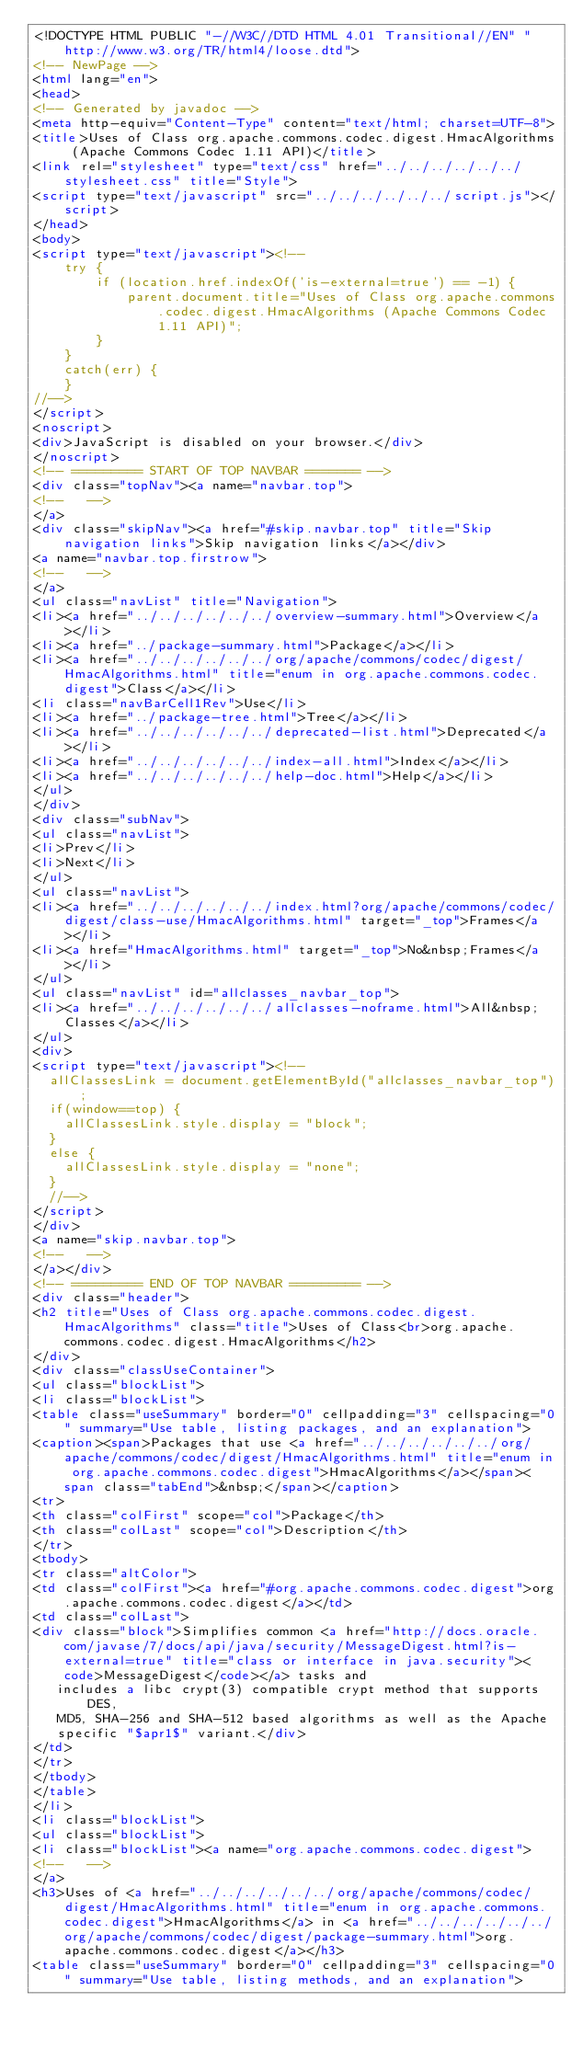Convert code to text. <code><loc_0><loc_0><loc_500><loc_500><_HTML_><!DOCTYPE HTML PUBLIC "-//W3C//DTD HTML 4.01 Transitional//EN" "http://www.w3.org/TR/html4/loose.dtd">
<!-- NewPage -->
<html lang="en">
<head>
<!-- Generated by javadoc -->
<meta http-equiv="Content-Type" content="text/html; charset=UTF-8">
<title>Uses of Class org.apache.commons.codec.digest.HmacAlgorithms (Apache Commons Codec 1.11 API)</title>
<link rel="stylesheet" type="text/css" href="../../../../../../stylesheet.css" title="Style">
<script type="text/javascript" src="../../../../../../script.js"></script>
</head>
<body>
<script type="text/javascript"><!--
    try {
        if (location.href.indexOf('is-external=true') == -1) {
            parent.document.title="Uses of Class org.apache.commons.codec.digest.HmacAlgorithms (Apache Commons Codec 1.11 API)";
        }
    }
    catch(err) {
    }
//-->
</script>
<noscript>
<div>JavaScript is disabled on your browser.</div>
</noscript>
<!-- ========= START OF TOP NAVBAR ======= -->
<div class="topNav"><a name="navbar.top">
<!--   -->
</a>
<div class="skipNav"><a href="#skip.navbar.top" title="Skip navigation links">Skip navigation links</a></div>
<a name="navbar.top.firstrow">
<!--   -->
</a>
<ul class="navList" title="Navigation">
<li><a href="../../../../../../overview-summary.html">Overview</a></li>
<li><a href="../package-summary.html">Package</a></li>
<li><a href="../../../../../../org/apache/commons/codec/digest/HmacAlgorithms.html" title="enum in org.apache.commons.codec.digest">Class</a></li>
<li class="navBarCell1Rev">Use</li>
<li><a href="../package-tree.html">Tree</a></li>
<li><a href="../../../../../../deprecated-list.html">Deprecated</a></li>
<li><a href="../../../../../../index-all.html">Index</a></li>
<li><a href="../../../../../../help-doc.html">Help</a></li>
</ul>
</div>
<div class="subNav">
<ul class="navList">
<li>Prev</li>
<li>Next</li>
</ul>
<ul class="navList">
<li><a href="../../../../../../index.html?org/apache/commons/codec/digest/class-use/HmacAlgorithms.html" target="_top">Frames</a></li>
<li><a href="HmacAlgorithms.html" target="_top">No&nbsp;Frames</a></li>
</ul>
<ul class="navList" id="allclasses_navbar_top">
<li><a href="../../../../../../allclasses-noframe.html">All&nbsp;Classes</a></li>
</ul>
<div>
<script type="text/javascript"><!--
  allClassesLink = document.getElementById("allclasses_navbar_top");
  if(window==top) {
    allClassesLink.style.display = "block";
  }
  else {
    allClassesLink.style.display = "none";
  }
  //-->
</script>
</div>
<a name="skip.navbar.top">
<!--   -->
</a></div>
<!-- ========= END OF TOP NAVBAR ========= -->
<div class="header">
<h2 title="Uses of Class org.apache.commons.codec.digest.HmacAlgorithms" class="title">Uses of Class<br>org.apache.commons.codec.digest.HmacAlgorithms</h2>
</div>
<div class="classUseContainer">
<ul class="blockList">
<li class="blockList">
<table class="useSummary" border="0" cellpadding="3" cellspacing="0" summary="Use table, listing packages, and an explanation">
<caption><span>Packages that use <a href="../../../../../../org/apache/commons/codec/digest/HmacAlgorithms.html" title="enum in org.apache.commons.codec.digest">HmacAlgorithms</a></span><span class="tabEnd">&nbsp;</span></caption>
<tr>
<th class="colFirst" scope="col">Package</th>
<th class="colLast" scope="col">Description</th>
</tr>
<tbody>
<tr class="altColor">
<td class="colFirst"><a href="#org.apache.commons.codec.digest">org.apache.commons.codec.digest</a></td>
<td class="colLast">
<div class="block">Simplifies common <a href="http://docs.oracle.com/javase/7/docs/api/java/security/MessageDigest.html?is-external=true" title="class or interface in java.security"><code>MessageDigest</code></a> tasks and
   includes a libc crypt(3) compatible crypt method that supports DES,
   MD5, SHA-256 and SHA-512 based algorithms as well as the Apache
   specific "$apr1$" variant.</div>
</td>
</tr>
</tbody>
</table>
</li>
<li class="blockList">
<ul class="blockList">
<li class="blockList"><a name="org.apache.commons.codec.digest">
<!--   -->
</a>
<h3>Uses of <a href="../../../../../../org/apache/commons/codec/digest/HmacAlgorithms.html" title="enum in org.apache.commons.codec.digest">HmacAlgorithms</a> in <a href="../../../../../../org/apache/commons/codec/digest/package-summary.html">org.apache.commons.codec.digest</a></h3>
<table class="useSummary" border="0" cellpadding="3" cellspacing="0" summary="Use table, listing methods, and an explanation"></code> 